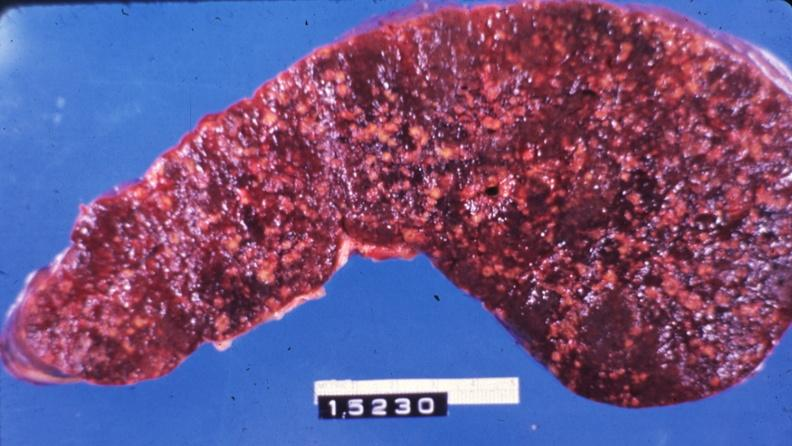does this image show slice of spleen with multiple nodules?
Answer the question using a single word or phrase. Yes 